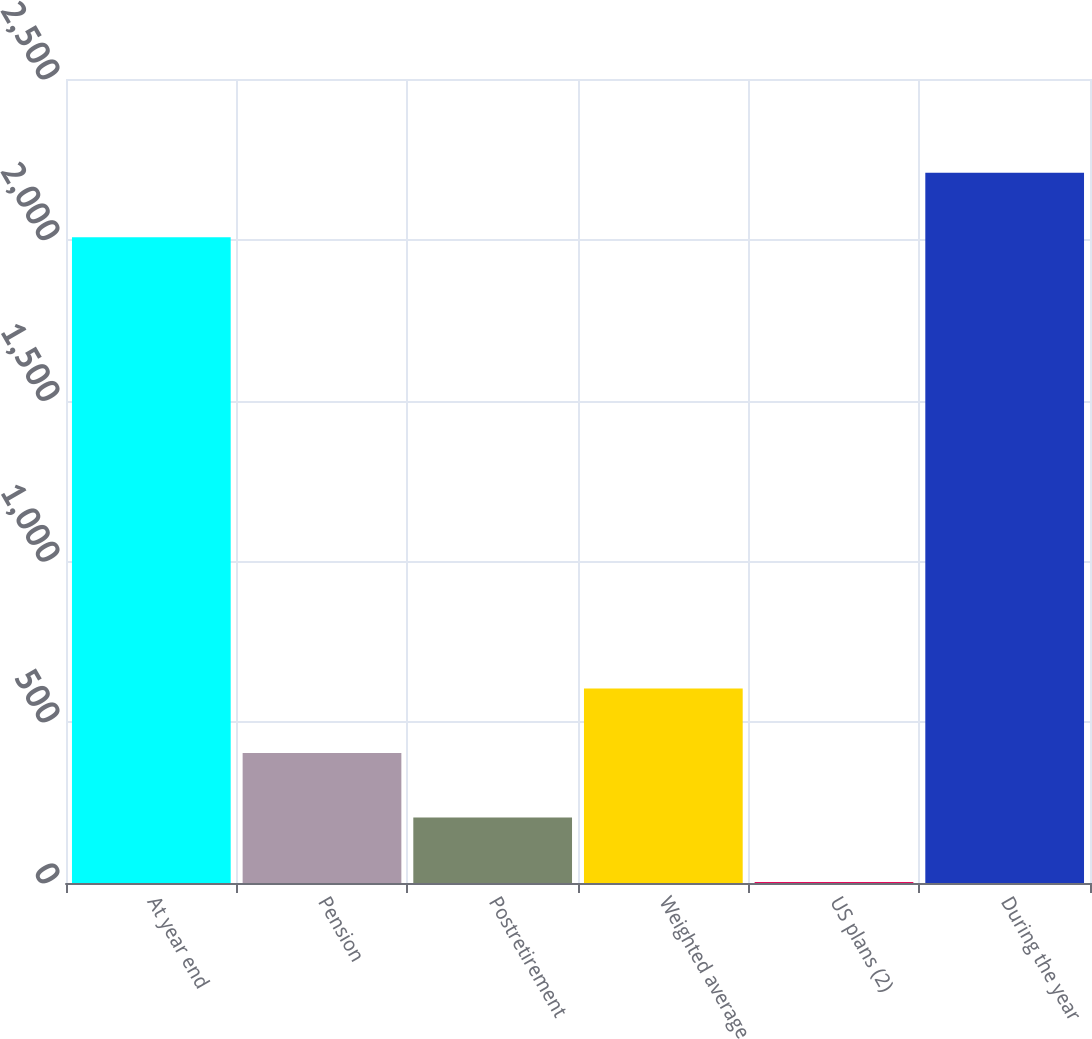Convert chart to OTSL. <chart><loc_0><loc_0><loc_500><loc_500><bar_chart><fcel>At year end<fcel>Pension<fcel>Postretirement<fcel>Weighted average<fcel>US plans (2)<fcel>During the year<nl><fcel>2008<fcel>404<fcel>203.5<fcel>604.5<fcel>3<fcel>2208.5<nl></chart> 